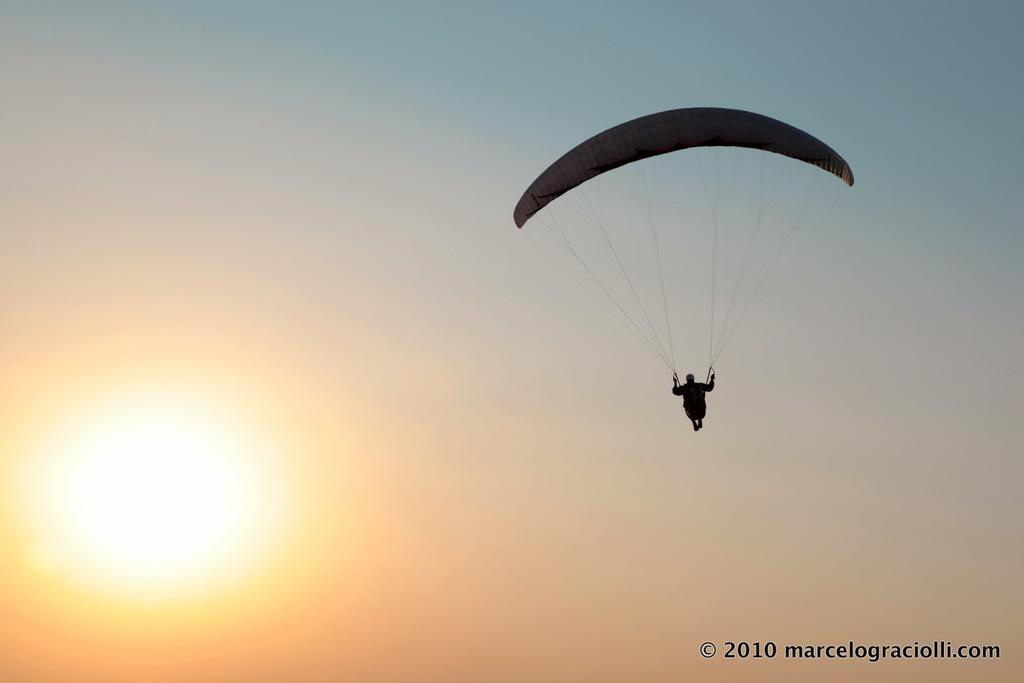Who is present in the image? There is a man in the image. What is the man doing in the image? The man is flying in the sky. What is the man wearing to ensure his safety while flying? The man is wearing a parachute. What celestial body can be seen in the image? There is a sun in the left side of the image. How many sisters does the man have in the image? There is no information about the man's sisters in the image. Is the man crying while flying in the image? There is no indication that the man is crying in the image. 